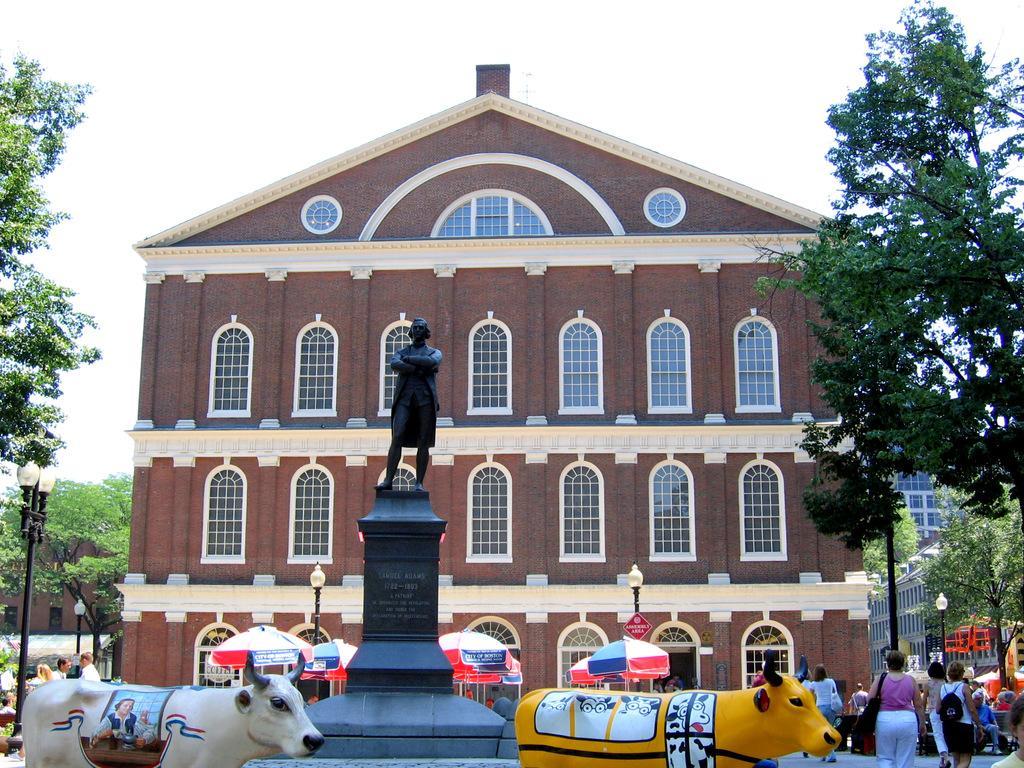Please provide a concise description of this image. In this picture we can observe a black color statue and statues of cows which are in white and yellow color. We can observe some people here. There are umbrella which are in black and red color. We can observe a brown color building. There are trees and a sky in the background. 